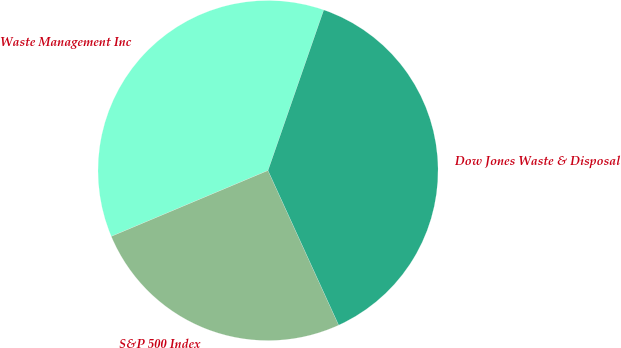<chart> <loc_0><loc_0><loc_500><loc_500><pie_chart><fcel>Waste Management Inc<fcel>S&P 500 Index<fcel>Dow Jones Waste & Disposal<nl><fcel>36.65%<fcel>25.49%<fcel>37.86%<nl></chart> 